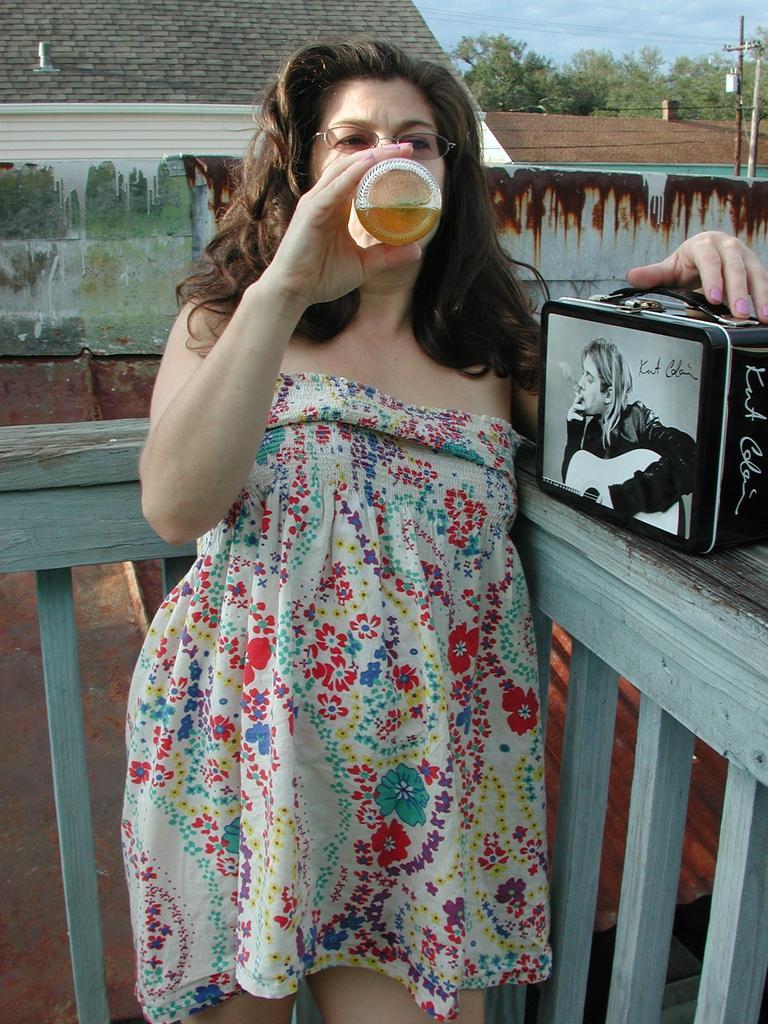Could you give a brief overview of what you see in this image? In this picture we can see a woman and in the background we can see a roof,trees,sky. 